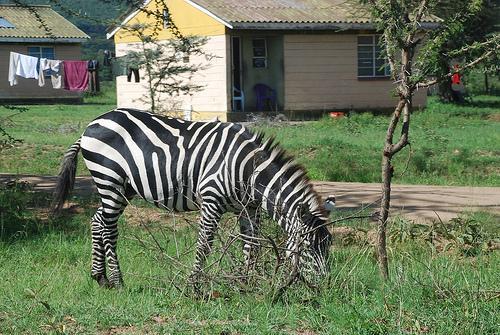How many houses are visible?
Give a very brief answer. 2. 